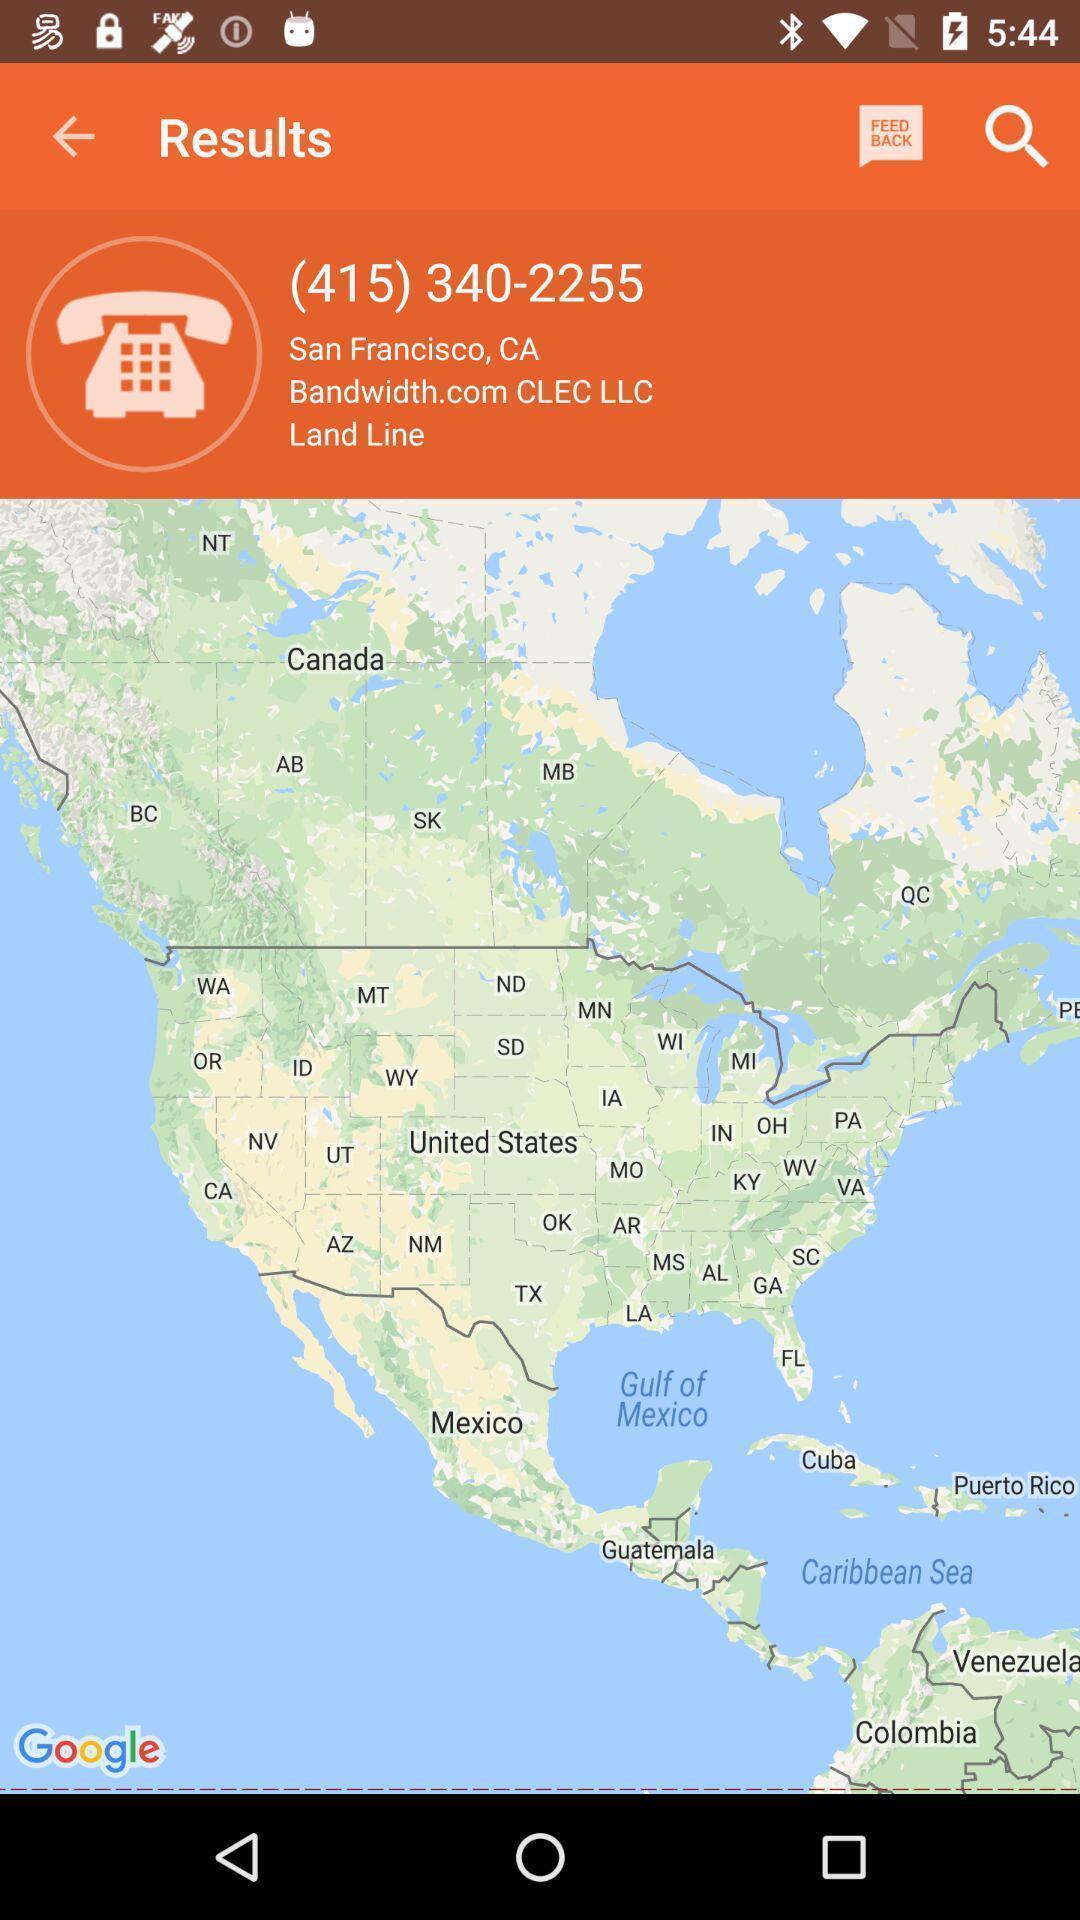Give me a summary of this screen capture. Search result of contact with map. 